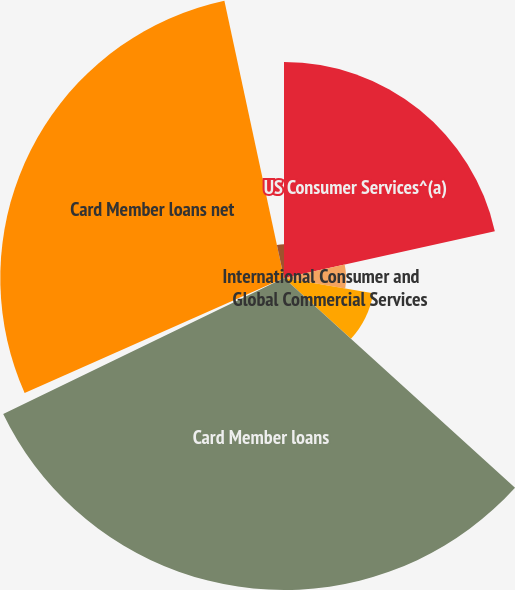<chart> <loc_0><loc_0><loc_500><loc_500><pie_chart><fcel>US Consumer Services^(a)<fcel>International Consumer and<fcel>Global Commercial Services<fcel>Card Member loans<fcel>Less Reserve for losses<fcel>Card Member loans net<fcel>Other loans net^(b)<nl><fcel>21.52%<fcel>6.19%<fcel>9.02%<fcel>31.09%<fcel>0.54%<fcel>28.27%<fcel>3.37%<nl></chart> 